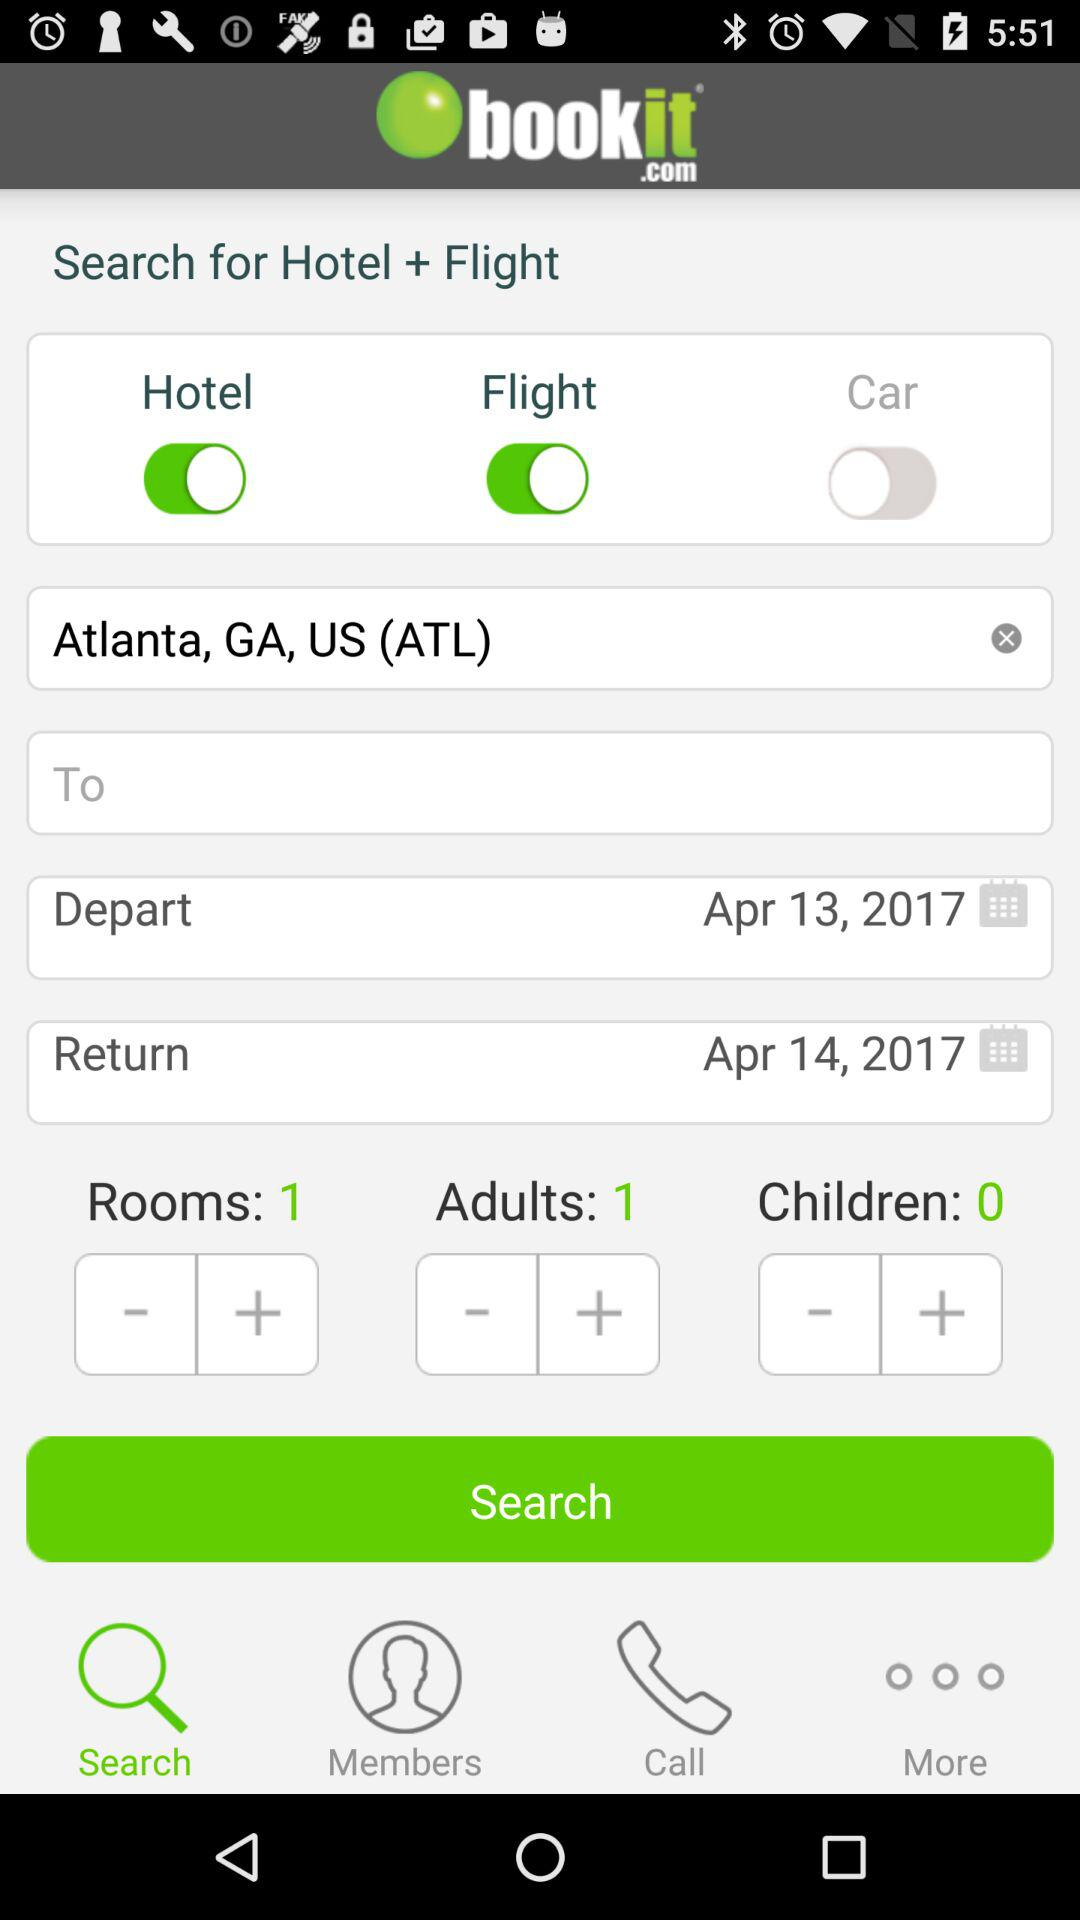What is the chosen number of rooms? The chosen number of rooms is 1. 